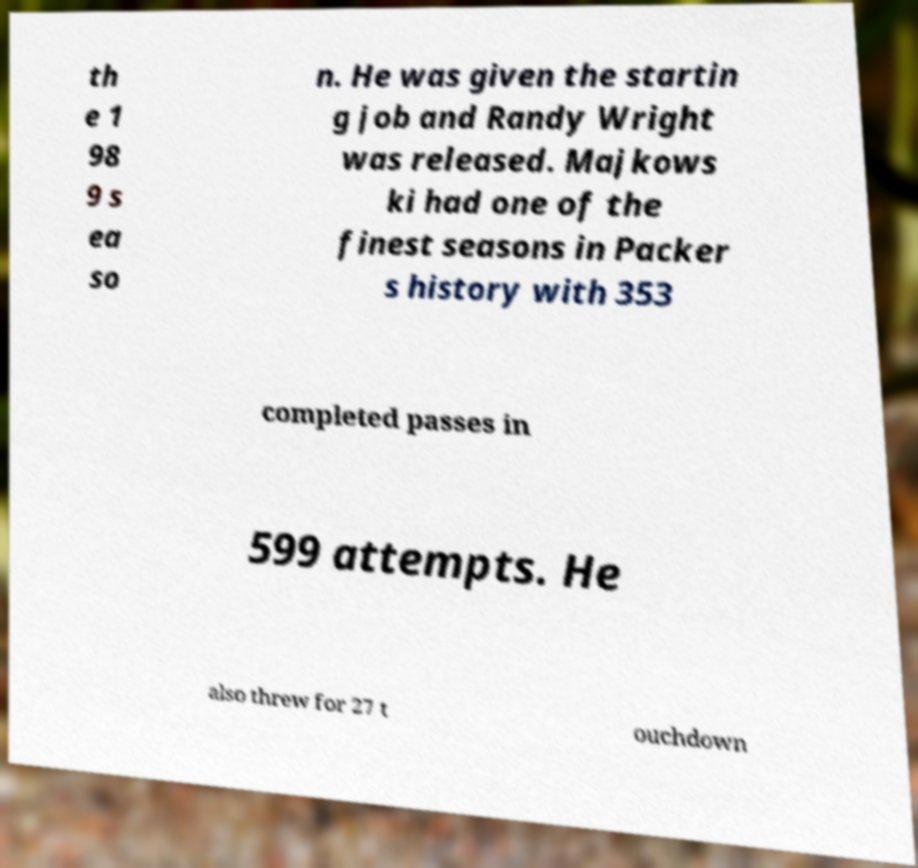Can you read and provide the text displayed in the image?This photo seems to have some interesting text. Can you extract and type it out for me? th e 1 98 9 s ea so n. He was given the startin g job and Randy Wright was released. Majkows ki had one of the finest seasons in Packer s history with 353 completed passes in 599 attempts. He also threw for 27 t ouchdown 